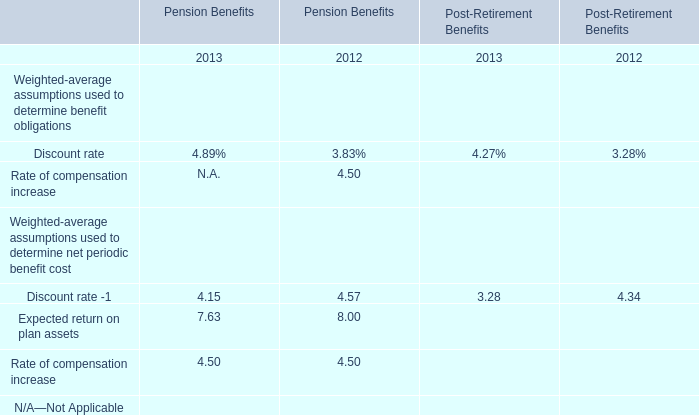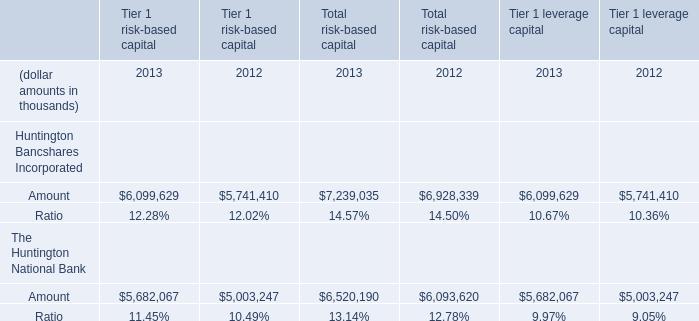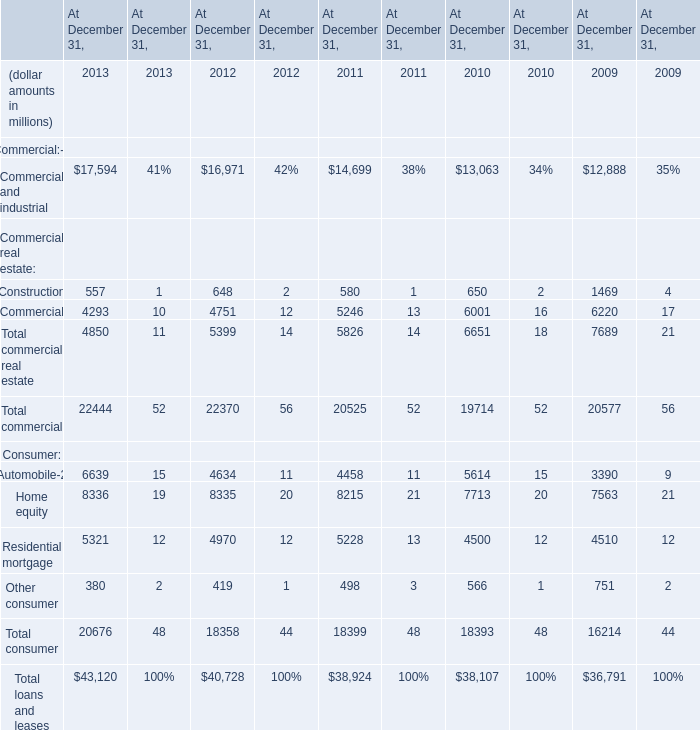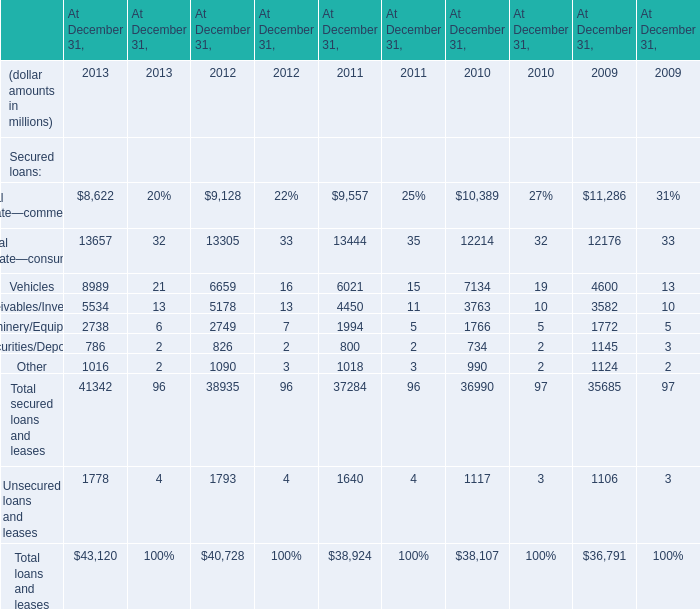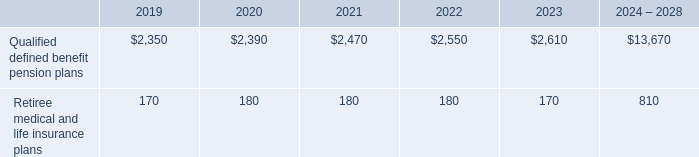what was the percentage of the change in the employee matching contributions from 2017 to 2018 
Computations: ((658 - 613) / 613)
Answer: 0.07341. 